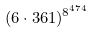<formula> <loc_0><loc_0><loc_500><loc_500>( 6 \cdot 3 6 1 ) ^ { 8 ^ { 4 7 4 } }</formula> 